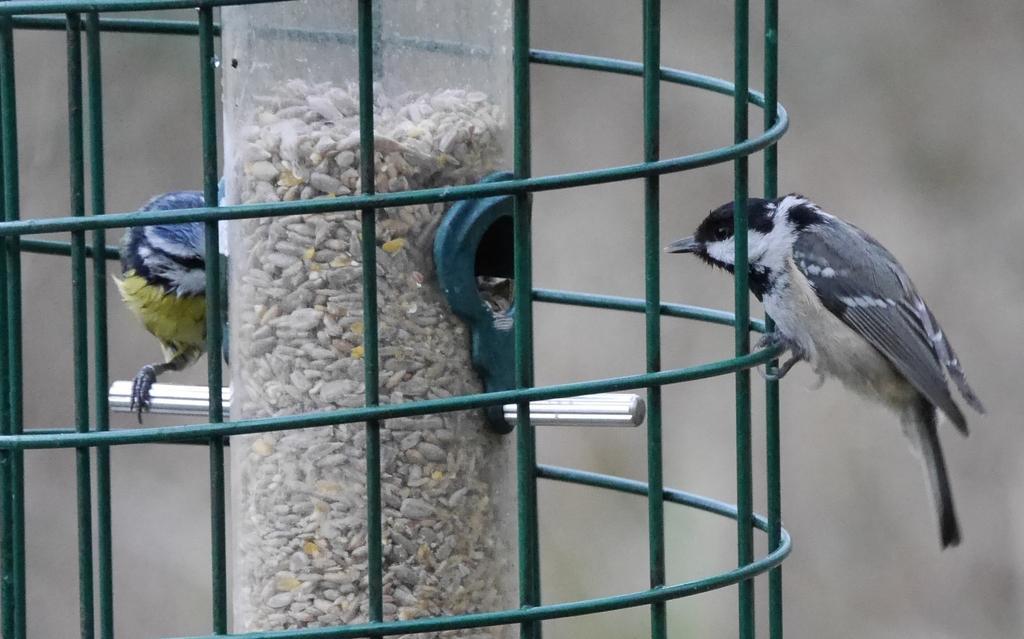Describe this image in one or two sentences. As we can see in the image there is cage and two birds. The background is blurred. 